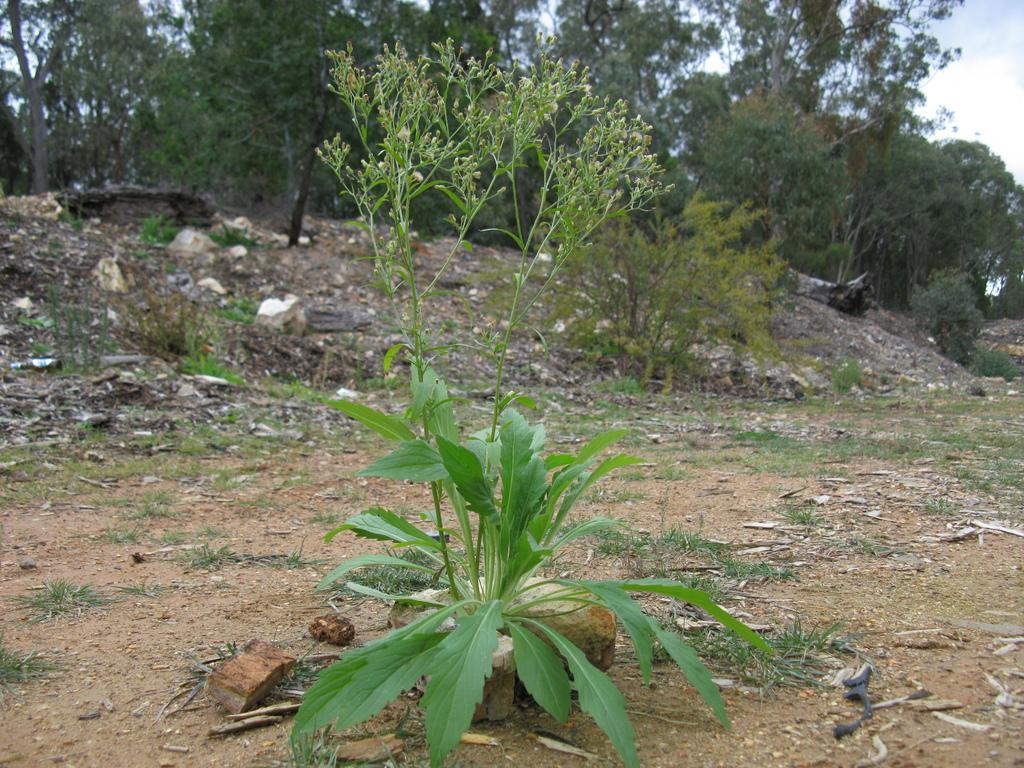What is the primary characteristic of the land in the image? The land in the image contains a lot of dust. What type of vegetation can be seen on the land? There are plants on the land. What can be seen in the background of the image? There are many trees in the background of the image. What type of scent can be detected from the plants in the image? There is no information about the scent of the plants in the image, so it cannot be determined. 